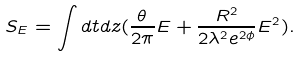Convert formula to latex. <formula><loc_0><loc_0><loc_500><loc_500>S _ { E } = \int d t d z ( \frac { \theta } { 2 \pi } E + \frac { R ^ { 2 } } { 2 \lambda ^ { 2 } e ^ { 2 \phi } } E ^ { 2 } ) .</formula> 